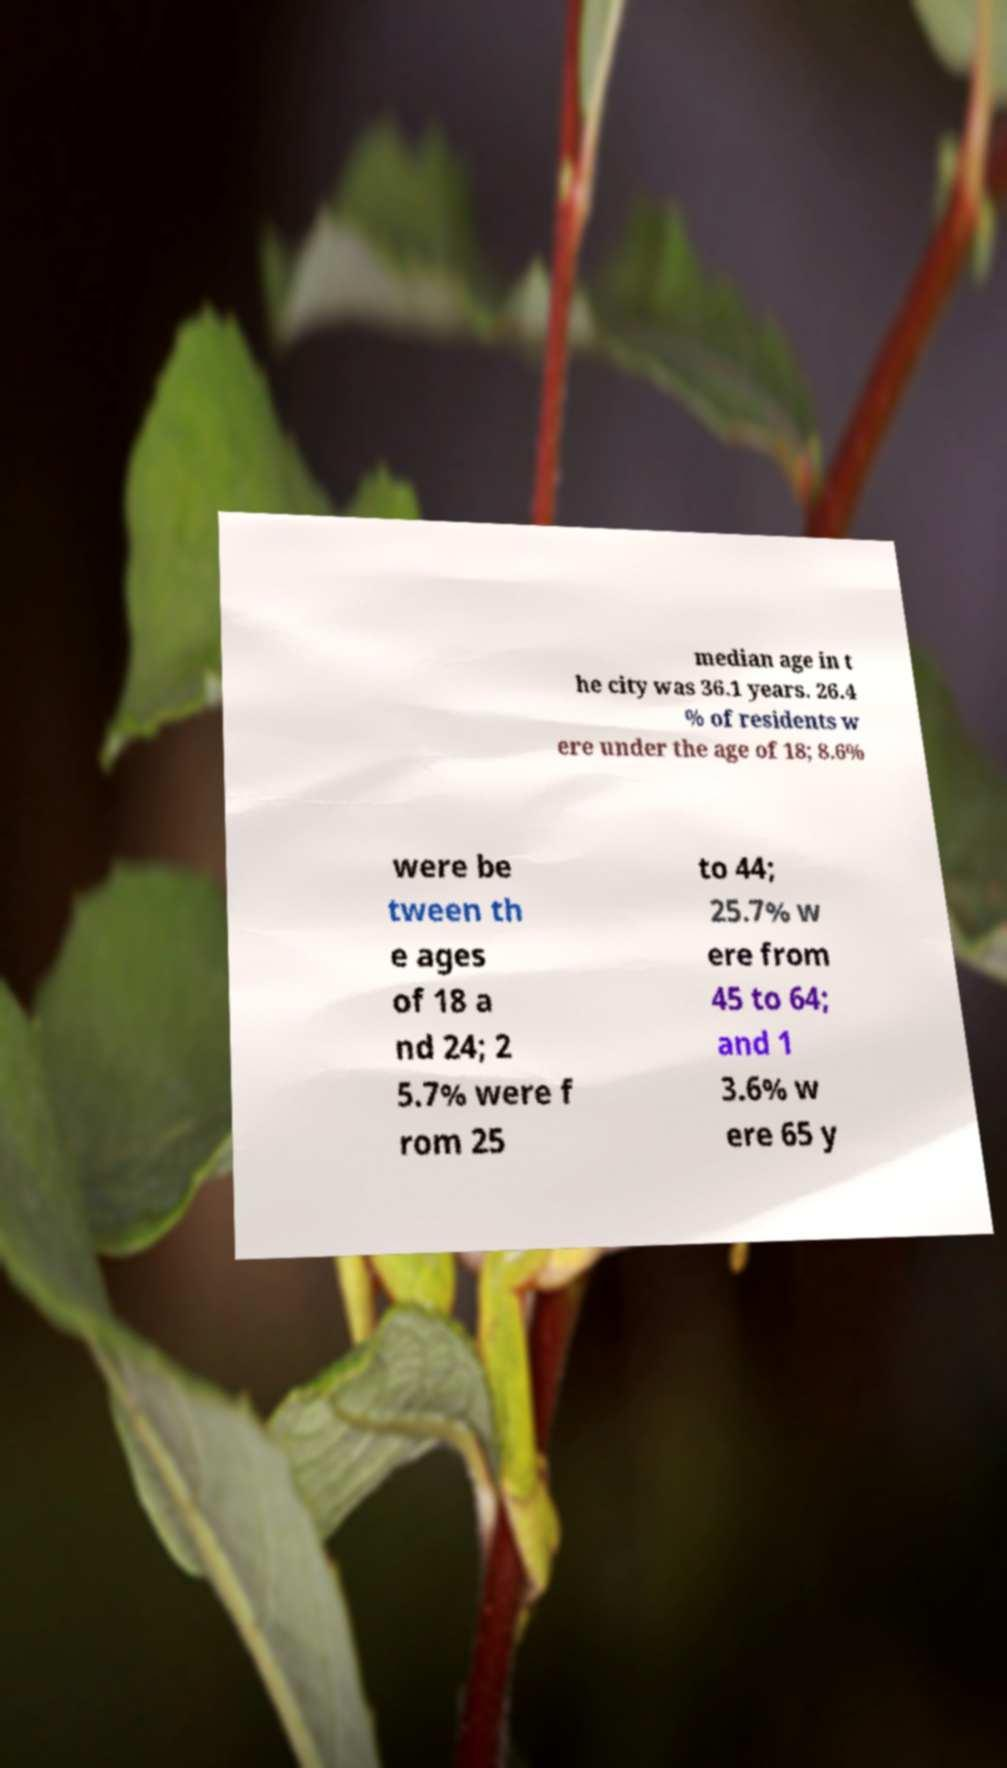Can you accurately transcribe the text from the provided image for me? median age in t he city was 36.1 years. 26.4 % of residents w ere under the age of 18; 8.6% were be tween th e ages of 18 a nd 24; 2 5.7% were f rom 25 to 44; 25.7% w ere from 45 to 64; and 1 3.6% w ere 65 y 